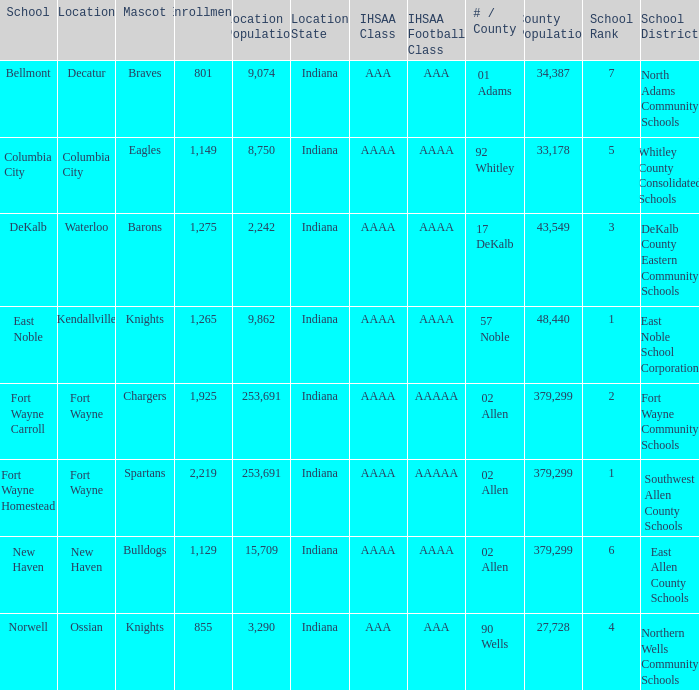What's the IHSAA Football Class in Decatur with an AAA IHSAA class? AAA. 